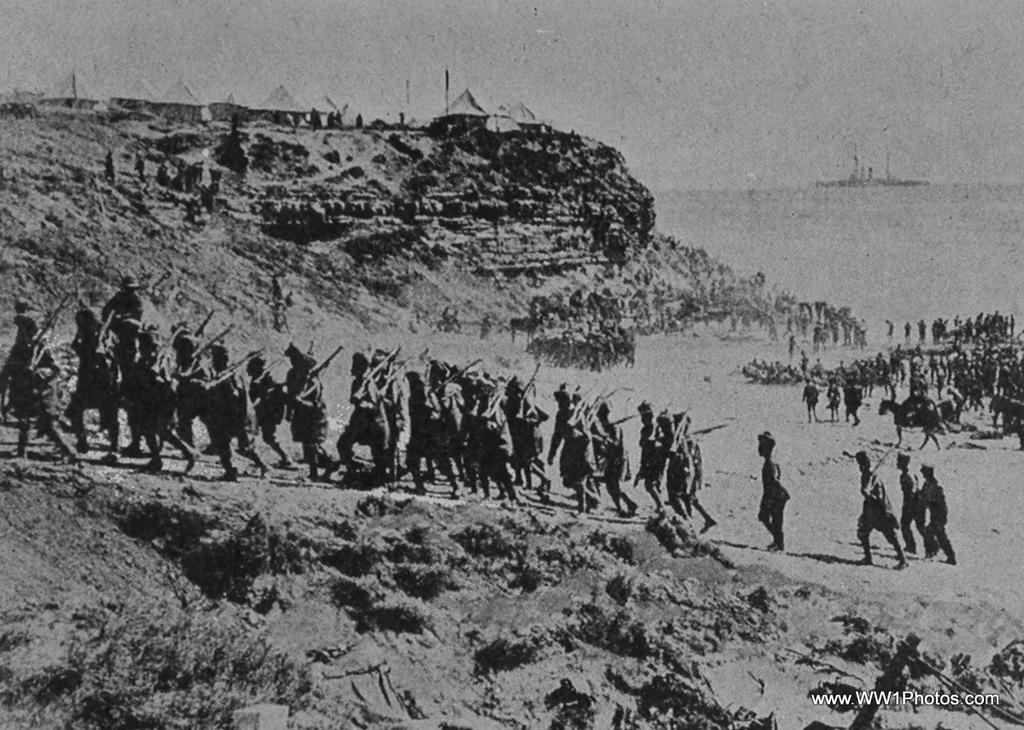How would you summarize this image in a sentence or two? In this picture I can see there are few people climbing the mountain which is on the left side, there are a few plants and there is a group of people standing on the right side, there are a few tents on the mountain and this is a black and white picture and the sky is clear. 